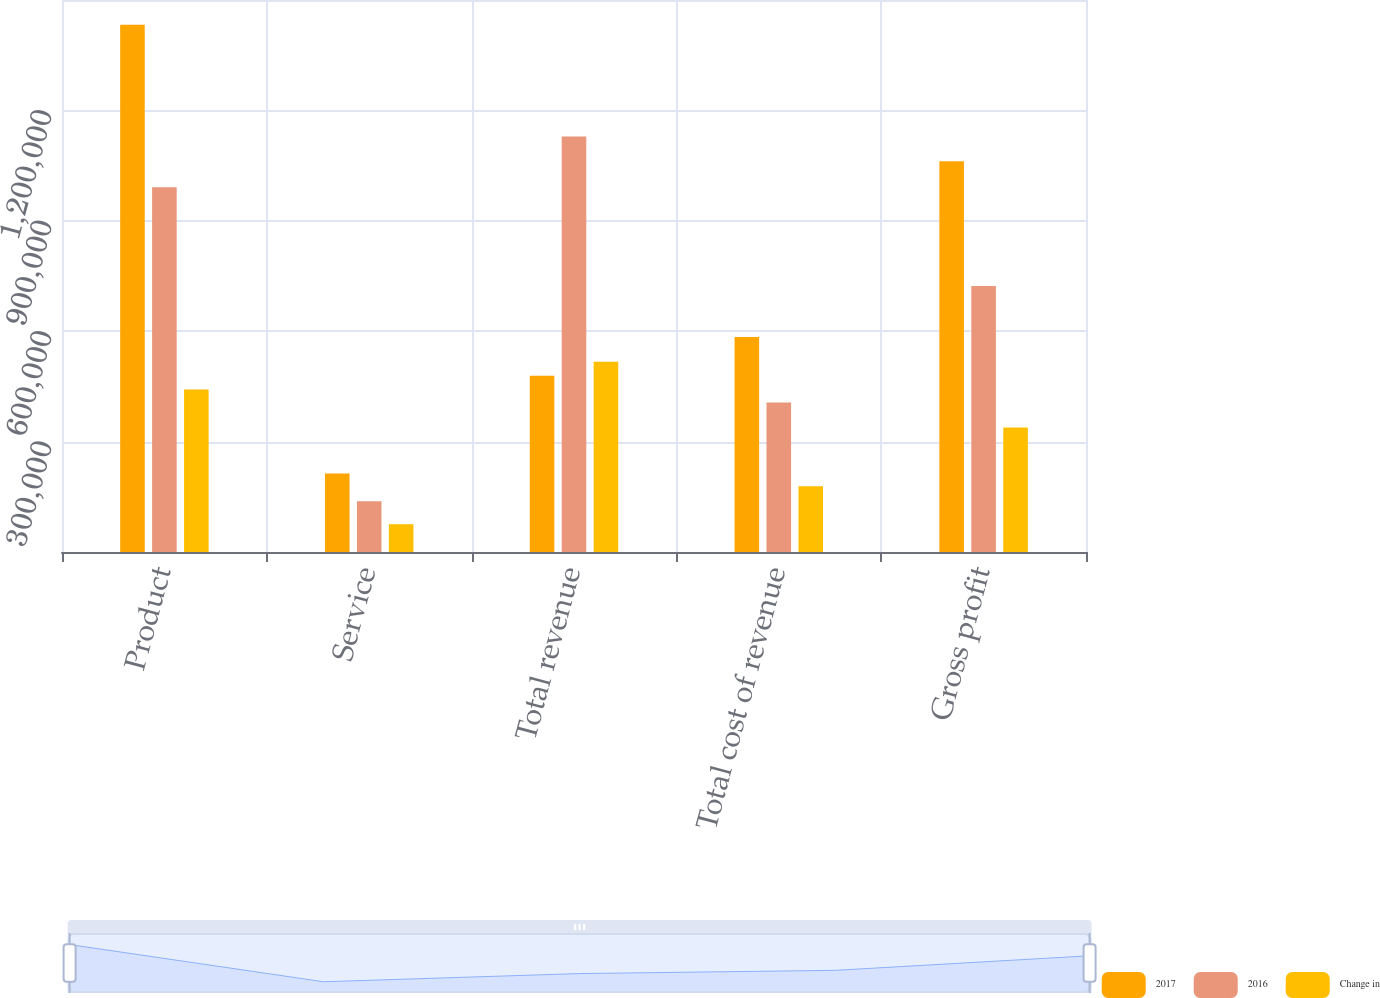Convert chart. <chart><loc_0><loc_0><loc_500><loc_500><stacked_bar_chart><ecel><fcel>Product<fcel>Service<fcel>Total revenue<fcel>Total cost of revenue<fcel>Gross profit<nl><fcel>2017<fcel>1.43281e+06<fcel>213376<fcel>479246<fcel>584417<fcel>1.06177e+06<nl><fcel>2016<fcel>991337<fcel>137830<fcel>1.12917e+06<fcel>406051<fcel>723116<nl><fcel>Change in<fcel>441473<fcel>75546<fcel>517019<fcel>178366<fcel>338653<nl></chart> 